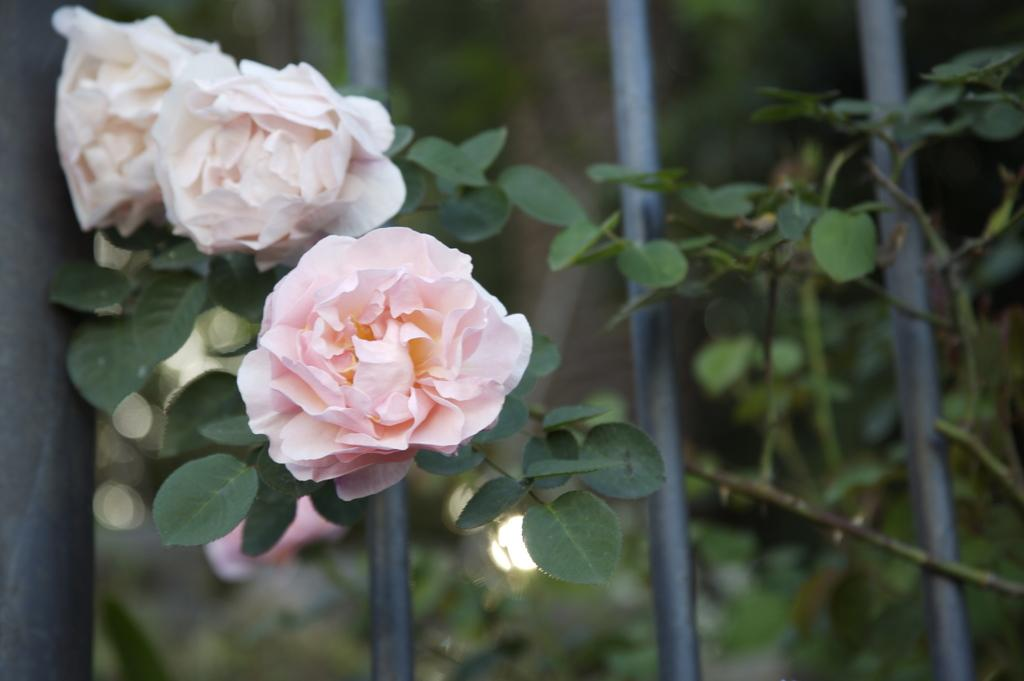What type of plants can be seen in the image? There are flowers in the image. What color are the flowers? The flowers are pink in color. What else can be seen in the image besides the flowers? There are leaves in the image. What color are the leaves? The leaves are green in color. What advice is being given in the image? There is no advice being given in the image; it features flowers and leaves. What scene is being depicted in the image? The image does not depict a specific scene; it simply shows flowers and leaves. 